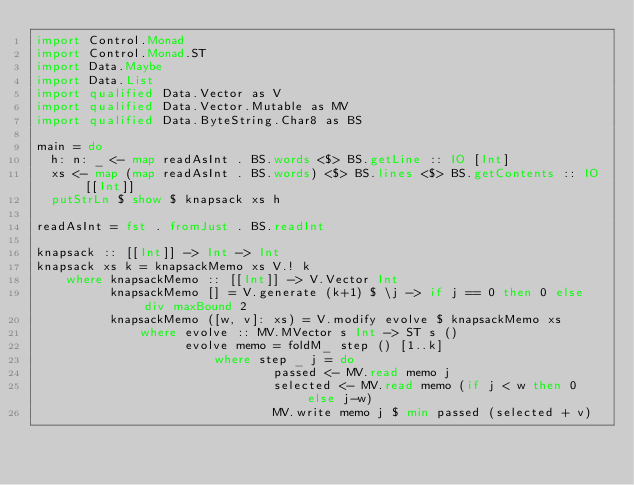Convert code to text. <code><loc_0><loc_0><loc_500><loc_500><_Haskell_>import Control.Monad
import Control.Monad.ST
import Data.Maybe
import Data.List
import qualified Data.Vector as V
import qualified Data.Vector.Mutable as MV
import qualified Data.ByteString.Char8 as BS

main = do
  h: n: _ <- map readAsInt . BS.words <$> BS.getLine :: IO [Int]
  xs <- map (map readAsInt . BS.words) <$> BS.lines <$> BS.getContents :: IO [[Int]]
  putStrLn $ show $ knapsack xs h

readAsInt = fst . fromJust . BS.readInt

knapsack :: [[Int]] -> Int -> Int
knapsack xs k = knapsackMemo xs V.! k
    where knapsackMemo :: [[Int]] -> V.Vector Int
          knapsackMemo [] = V.generate (k+1) $ \j -> if j == 0 then 0 else div maxBound 2
          knapsackMemo ([w, v]: xs) = V.modify evolve $ knapsackMemo xs
              where evolve :: MV.MVector s Int -> ST s ()
                    evolve memo = foldM_ step () [1..k]
                        where step _ j = do
                                passed <- MV.read memo j
                                selected <- MV.read memo (if j < w then 0 else j-w)
                                MV.write memo j $ min passed (selected + v)
</code> 